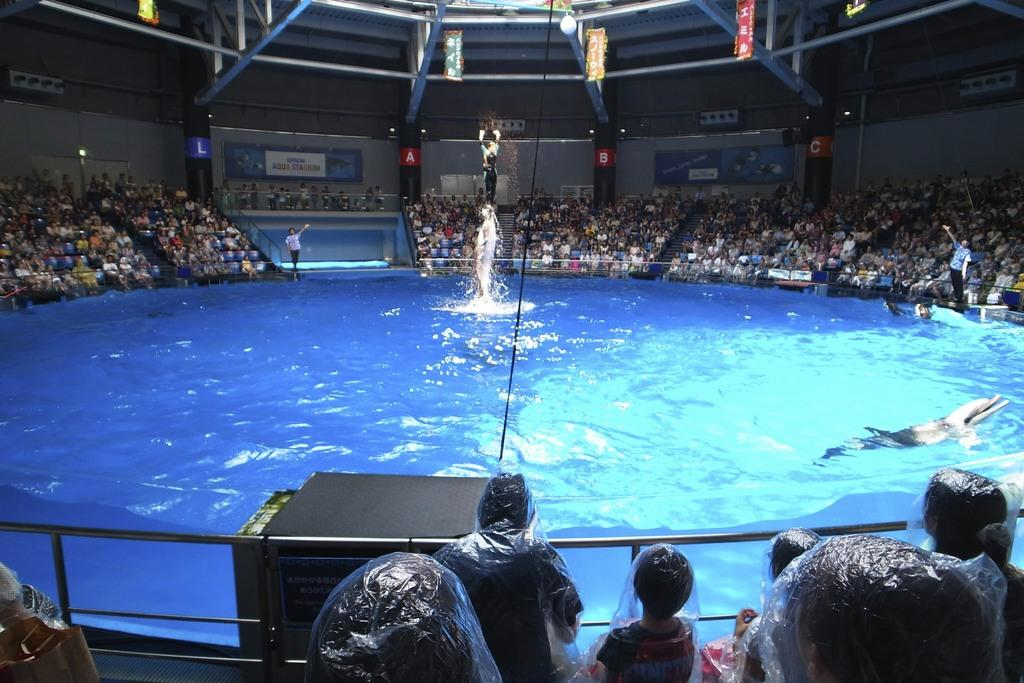What is the main focus of the audience in the image? The audience is watching a dolphin show. Where is the dolphin show taking place? The show is taking place near a pool in the middle of the image. What can be seen above the audience in the image? There is a roof at the top of the image. How many tomatoes are hanging from the tree in the image? There is no tree or tomatoes present in the image. What type of goldfish can be seen swimming in the pool during the dolphin show? There are no goldfish visible in the image; the focus is on the dolphin show. 